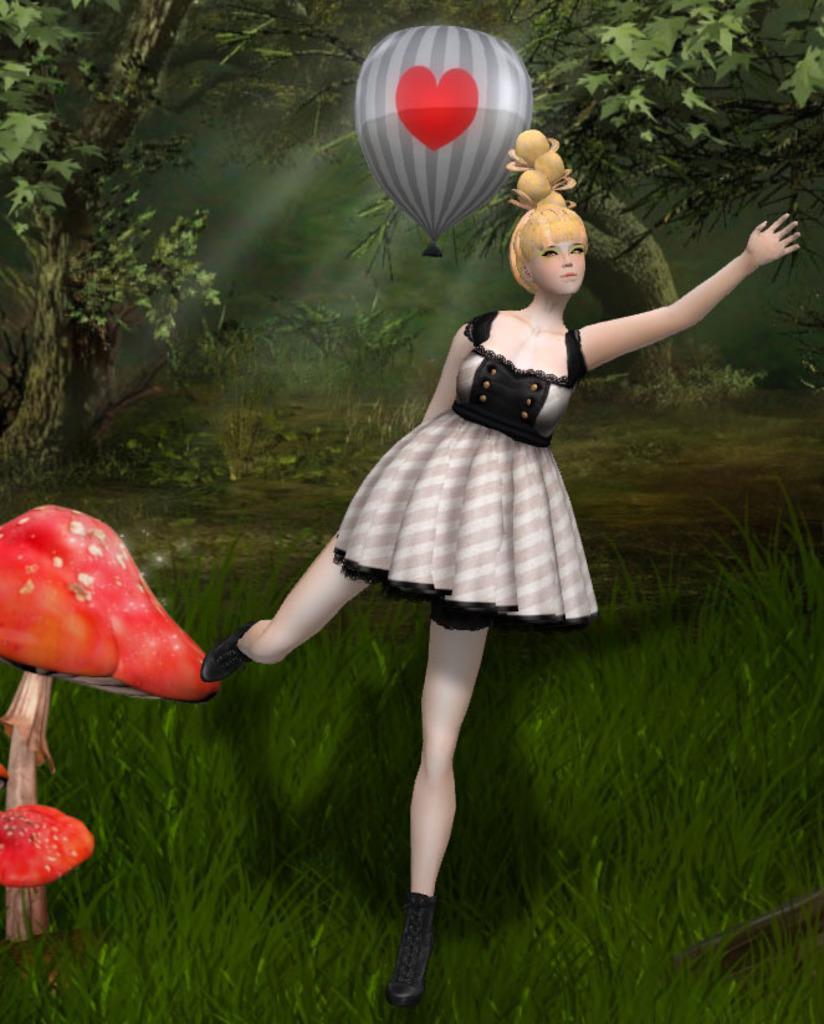How would you summarize this image in a sentence or two? In this image I can see a woman doll. She is wearing white and black dress. Back I can see balloon,trees and a red color mushroom. It is an animated picture. 